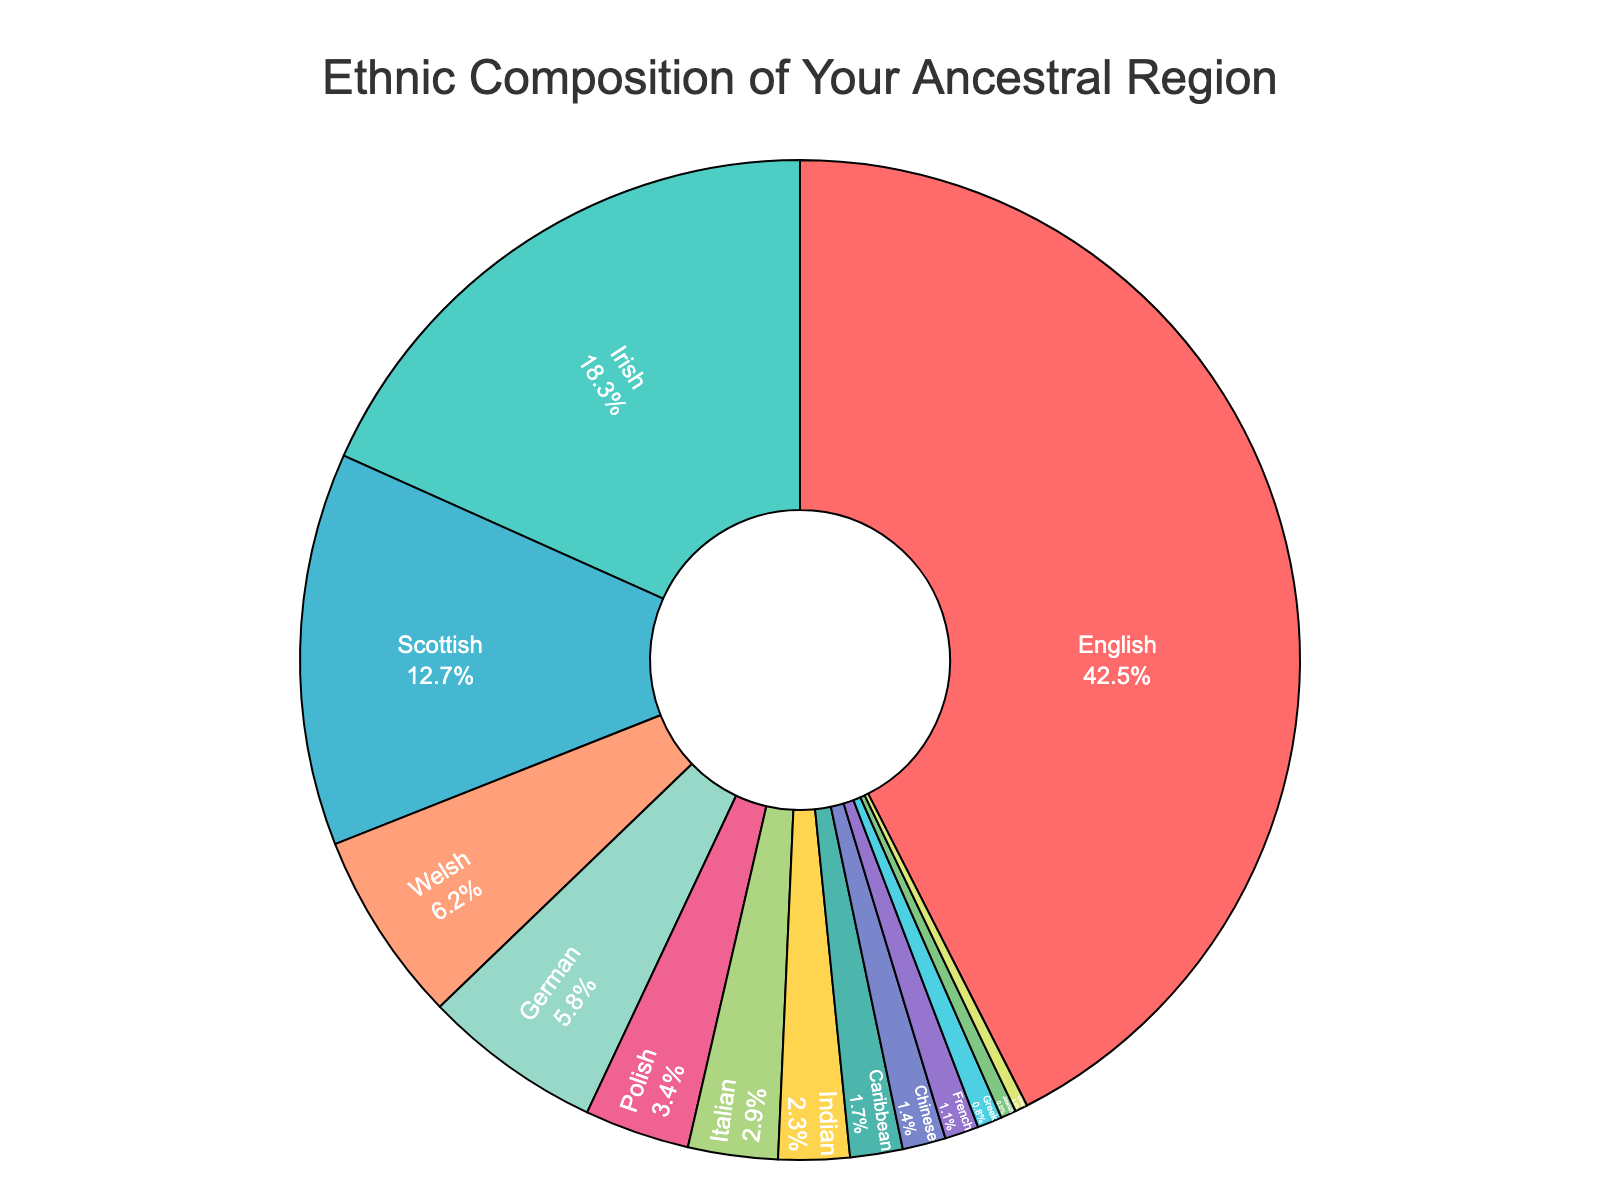What percentage of the ethnic composition is made up of English and Irish? To find the combined percentage of English and Irish, add the percentage values for both groups from the data: English (42.5%) + Irish (18.3%) = 60.8%
Answer: 60.8% Which ethnic group makes up the smallest proportion, and what percentage do they represent? The smallest proportion is represented by the ethnic group 'Other' with a percentage of 0.4%
Answer: Other, 0.4% How much larger is the English percentage compared to the German percentage? Subtract the German percentage from the English percentage: English (42.5%) - German (5.8%) = 36.7%
Answer: 36.7% Is the combined percentage of the Welsh and Scottish groups more or less than 20%? Add the percentages for Welsh (6.2%) and Scottish (12.7%) and check if the sum is more or less than 20: 6.2% + 12.7% = 18.9%, which is less than 20%
Answer: Less, 18.9% Which ethnic group has a percentage closest to 3%? The closest percentage to 3% is of the Italian ethnic group with 2.9%
Answer: Italian, 2.9% What is the difference in percentage between the Irish and the Italian ethnic groups? Subtract the Italian percentage from the Irish percentage: Irish (18.3%) - Italian (2.9%) = 15.4%
Answer: 15.4% What percentage of the ethnic composition is made up of non-European ethnic groups? Add the percentages of Indian (2.3%), Caribbean (1.7%), and Chinese (1.4%): 2.3% + 1.7% + 1.4% = 5.4%
Answer: 5.4% How many ethnic groups have a percentage greater than 5%? Ethnic groups with more than 5% are English (42.5%), Irish (18.3%), Scottish (12.7%), Welsh (6.2%), and German (5.8%). Count these groups: 5 groups
Answer: 5 Which color represents the Irish ethnic group in the pie chart? Without the actual visual, infer from the typical order of sorted data and specified color list. The most likely color for Irish, being the second largest segment, is '#4ECDC4' (greenish)
Answer: Greenish Is the Italian ethnic group's percentage more or less than the combined percentage of the Jewish and French groups? Add the Jewish (0.5%) and French (1.1%) percentages and compare it with Italian (2.9%): 0.5% + 1.1% = 1.6%, which is less than Italian's 2.9%
Answer: More, 2.9% 